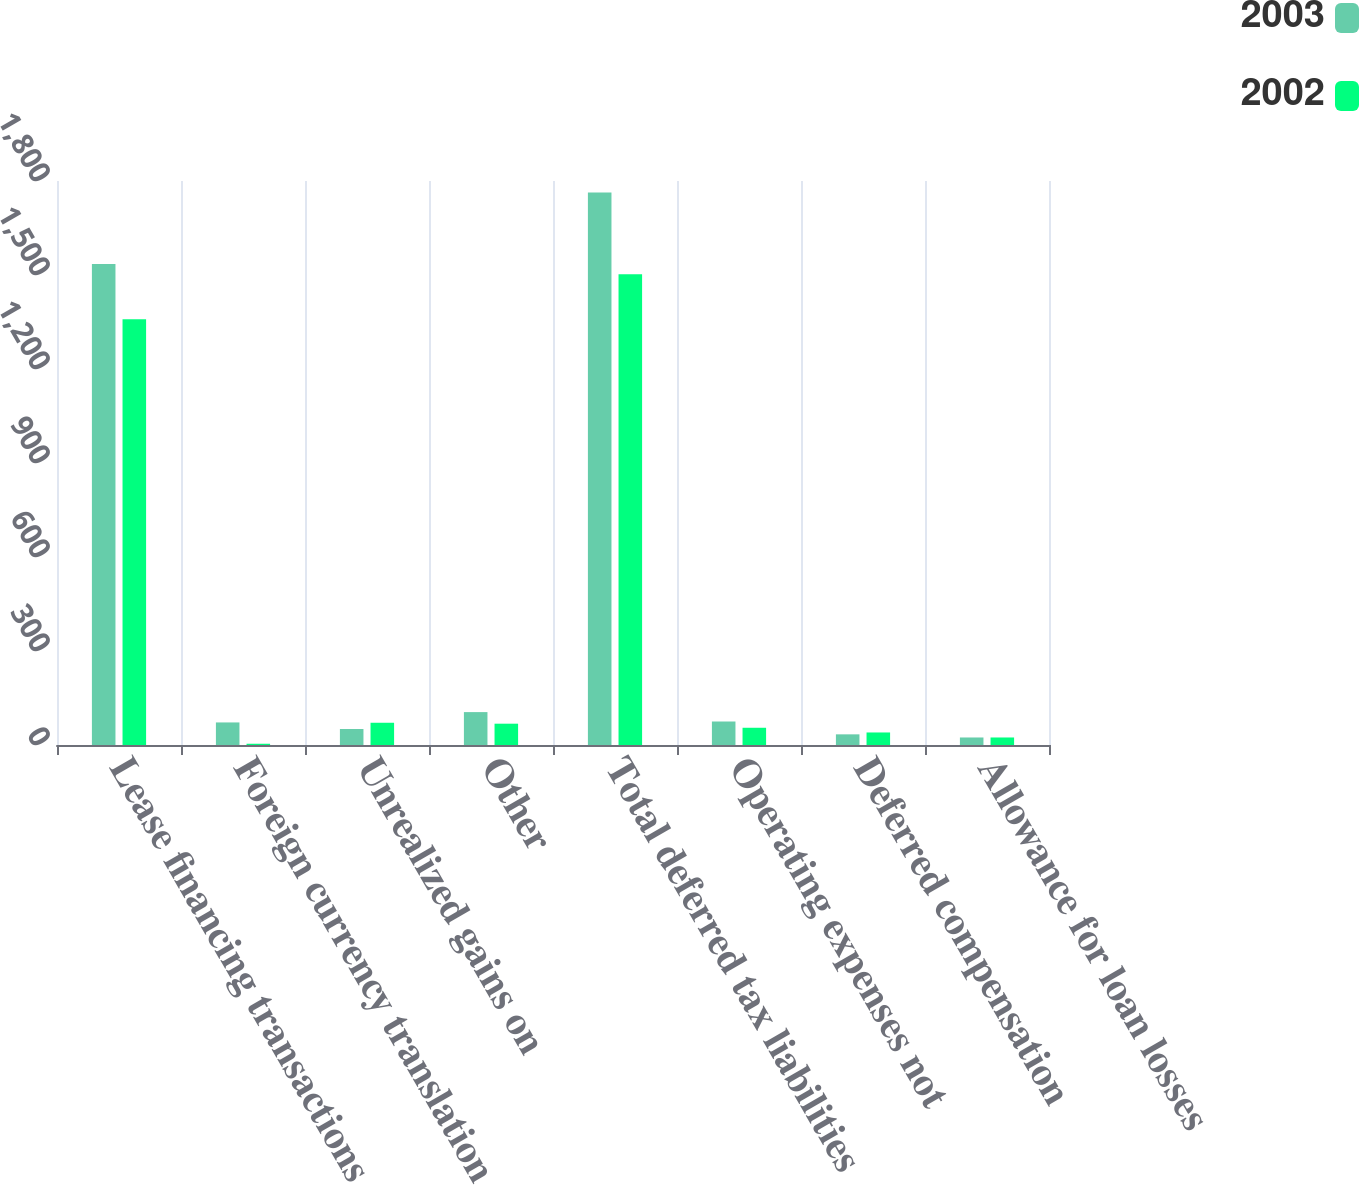<chart> <loc_0><loc_0><loc_500><loc_500><stacked_bar_chart><ecel><fcel>Lease financing transactions<fcel>Foreign currency translation<fcel>Unrealized gains on<fcel>Other<fcel>Total deferred tax liabilities<fcel>Operating expenses not<fcel>Deferred compensation<fcel>Allowance for loan losses<nl><fcel>2003<fcel>1535<fcel>72<fcel>51<fcel>105<fcel>1763<fcel>75<fcel>34<fcel>24<nl><fcel>2002<fcel>1359<fcel>4<fcel>71<fcel>68<fcel>1502<fcel>55<fcel>40<fcel>24<nl></chart> 